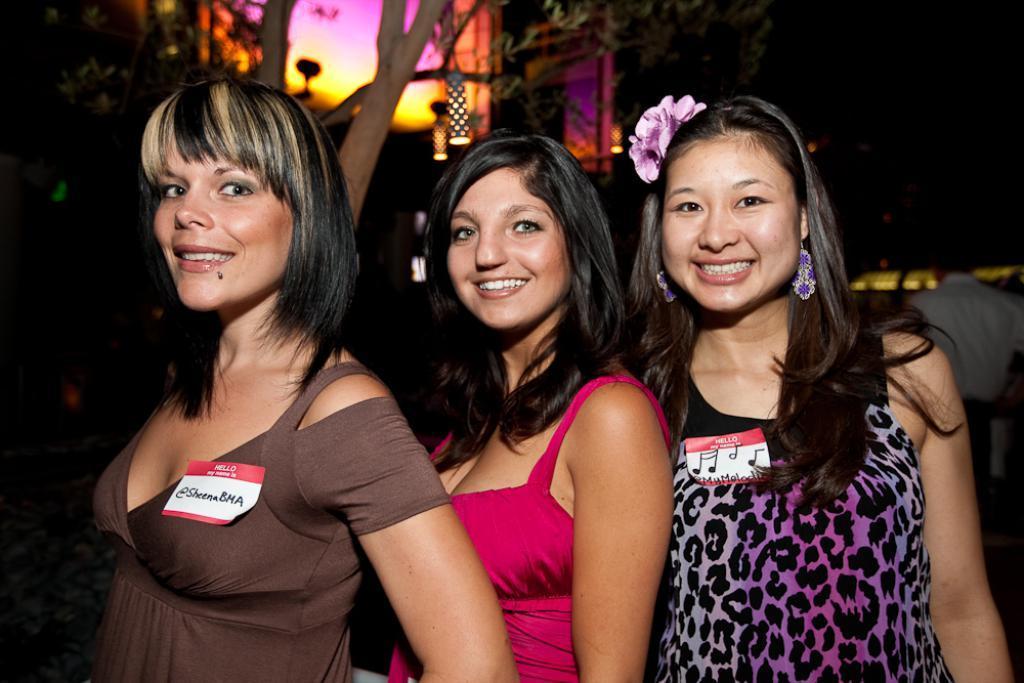How would you summarize this image in a sentence or two? This image consists of three women standing in the front. In the background, there are trees and lights. In the middle, the woman is wearing pink dress. 